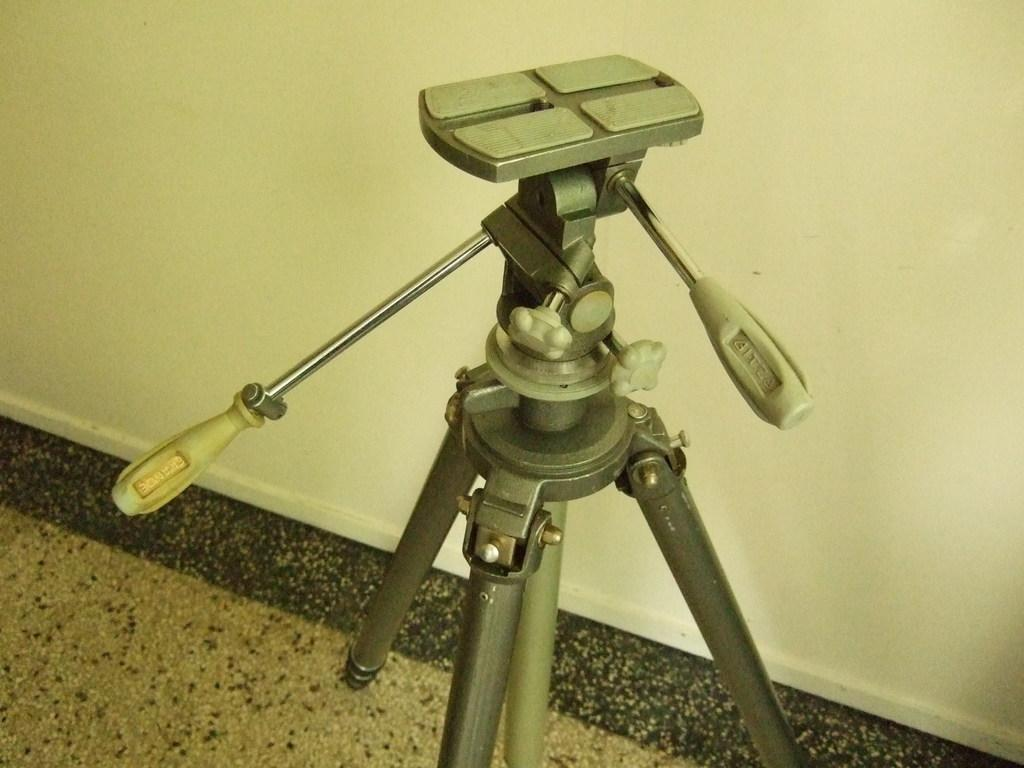What is located in the center of the image? There is a stand in the center of the image. What can be seen in the background of the image? There is a wall in the background of the image. What is visible at the bottom of the image? There is a floor visible at the bottom of the image. How much honey is being poured from the stand in the image? There is no honey or pouring action present in the image. 